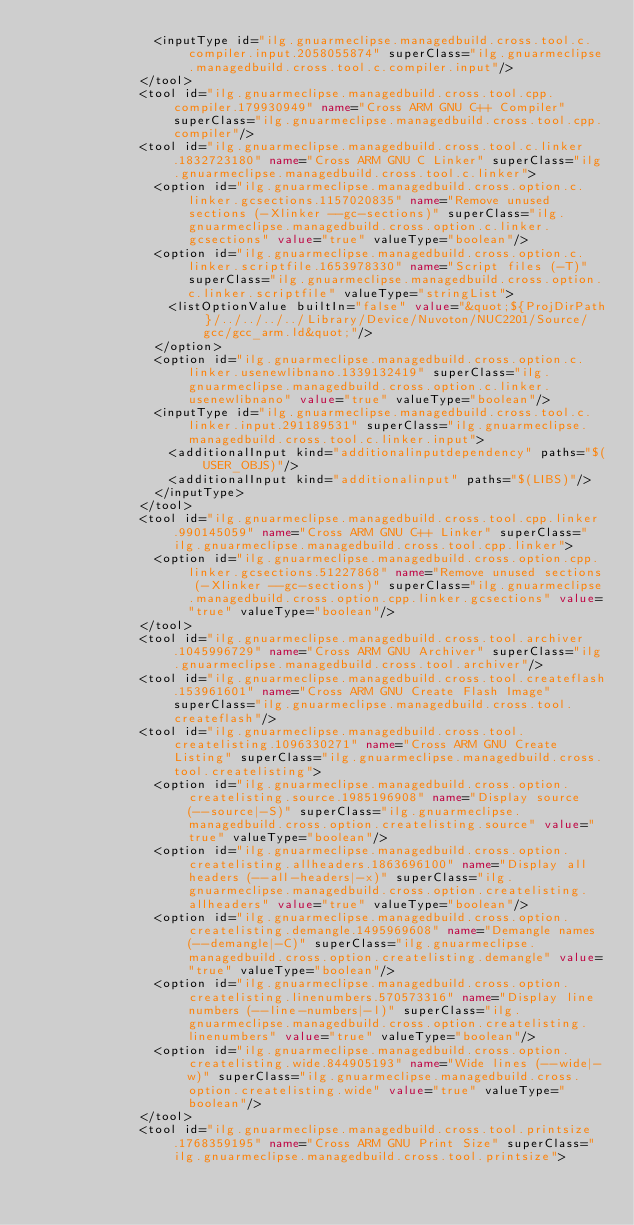<code> <loc_0><loc_0><loc_500><loc_500><_XML_>								<inputType id="ilg.gnuarmeclipse.managedbuild.cross.tool.c.compiler.input.2058055874" superClass="ilg.gnuarmeclipse.managedbuild.cross.tool.c.compiler.input"/>
							</tool>
							<tool id="ilg.gnuarmeclipse.managedbuild.cross.tool.cpp.compiler.179930949" name="Cross ARM GNU C++ Compiler" superClass="ilg.gnuarmeclipse.managedbuild.cross.tool.cpp.compiler"/>
							<tool id="ilg.gnuarmeclipse.managedbuild.cross.tool.c.linker.1832723180" name="Cross ARM GNU C Linker" superClass="ilg.gnuarmeclipse.managedbuild.cross.tool.c.linker">
								<option id="ilg.gnuarmeclipse.managedbuild.cross.option.c.linker.gcsections.1157020835" name="Remove unused sections (-Xlinker --gc-sections)" superClass="ilg.gnuarmeclipse.managedbuild.cross.option.c.linker.gcsections" value="true" valueType="boolean"/>
								<option id="ilg.gnuarmeclipse.managedbuild.cross.option.c.linker.scriptfile.1653978330" name="Script files (-T)" superClass="ilg.gnuarmeclipse.managedbuild.cross.option.c.linker.scriptfile" valueType="stringList">
									<listOptionValue builtIn="false" value="&quot;${ProjDirPath}/../../../../Library/Device/Nuvoton/NUC2201/Source/gcc/gcc_arm.ld&quot;"/>
								</option>
								<option id="ilg.gnuarmeclipse.managedbuild.cross.option.c.linker.usenewlibnano.1339132419" superClass="ilg.gnuarmeclipse.managedbuild.cross.option.c.linker.usenewlibnano" value="true" valueType="boolean"/>
								<inputType id="ilg.gnuarmeclipse.managedbuild.cross.tool.c.linker.input.291189531" superClass="ilg.gnuarmeclipse.managedbuild.cross.tool.c.linker.input">
									<additionalInput kind="additionalinputdependency" paths="$(USER_OBJS)"/>
									<additionalInput kind="additionalinput" paths="$(LIBS)"/>
								</inputType>
							</tool>
							<tool id="ilg.gnuarmeclipse.managedbuild.cross.tool.cpp.linker.990145059" name="Cross ARM GNU C++ Linker" superClass="ilg.gnuarmeclipse.managedbuild.cross.tool.cpp.linker">
								<option id="ilg.gnuarmeclipse.managedbuild.cross.option.cpp.linker.gcsections.51227868" name="Remove unused sections (-Xlinker --gc-sections)" superClass="ilg.gnuarmeclipse.managedbuild.cross.option.cpp.linker.gcsections" value="true" valueType="boolean"/>
							</tool>
							<tool id="ilg.gnuarmeclipse.managedbuild.cross.tool.archiver.1045996729" name="Cross ARM GNU Archiver" superClass="ilg.gnuarmeclipse.managedbuild.cross.tool.archiver"/>
							<tool id="ilg.gnuarmeclipse.managedbuild.cross.tool.createflash.153961601" name="Cross ARM GNU Create Flash Image" superClass="ilg.gnuarmeclipse.managedbuild.cross.tool.createflash"/>
							<tool id="ilg.gnuarmeclipse.managedbuild.cross.tool.createlisting.1096330271" name="Cross ARM GNU Create Listing" superClass="ilg.gnuarmeclipse.managedbuild.cross.tool.createlisting">
								<option id="ilg.gnuarmeclipse.managedbuild.cross.option.createlisting.source.1985196908" name="Display source (--source|-S)" superClass="ilg.gnuarmeclipse.managedbuild.cross.option.createlisting.source" value="true" valueType="boolean"/>
								<option id="ilg.gnuarmeclipse.managedbuild.cross.option.createlisting.allheaders.1863696100" name="Display all headers (--all-headers|-x)" superClass="ilg.gnuarmeclipse.managedbuild.cross.option.createlisting.allheaders" value="true" valueType="boolean"/>
								<option id="ilg.gnuarmeclipse.managedbuild.cross.option.createlisting.demangle.1495969608" name="Demangle names (--demangle|-C)" superClass="ilg.gnuarmeclipse.managedbuild.cross.option.createlisting.demangle" value="true" valueType="boolean"/>
								<option id="ilg.gnuarmeclipse.managedbuild.cross.option.createlisting.linenumbers.570573316" name="Display line numbers (--line-numbers|-l)" superClass="ilg.gnuarmeclipse.managedbuild.cross.option.createlisting.linenumbers" value="true" valueType="boolean"/>
								<option id="ilg.gnuarmeclipse.managedbuild.cross.option.createlisting.wide.844905193" name="Wide lines (--wide|-w)" superClass="ilg.gnuarmeclipse.managedbuild.cross.option.createlisting.wide" value="true" valueType="boolean"/>
							</tool>
							<tool id="ilg.gnuarmeclipse.managedbuild.cross.tool.printsize.1768359195" name="Cross ARM GNU Print Size" superClass="ilg.gnuarmeclipse.managedbuild.cross.tool.printsize"></code> 